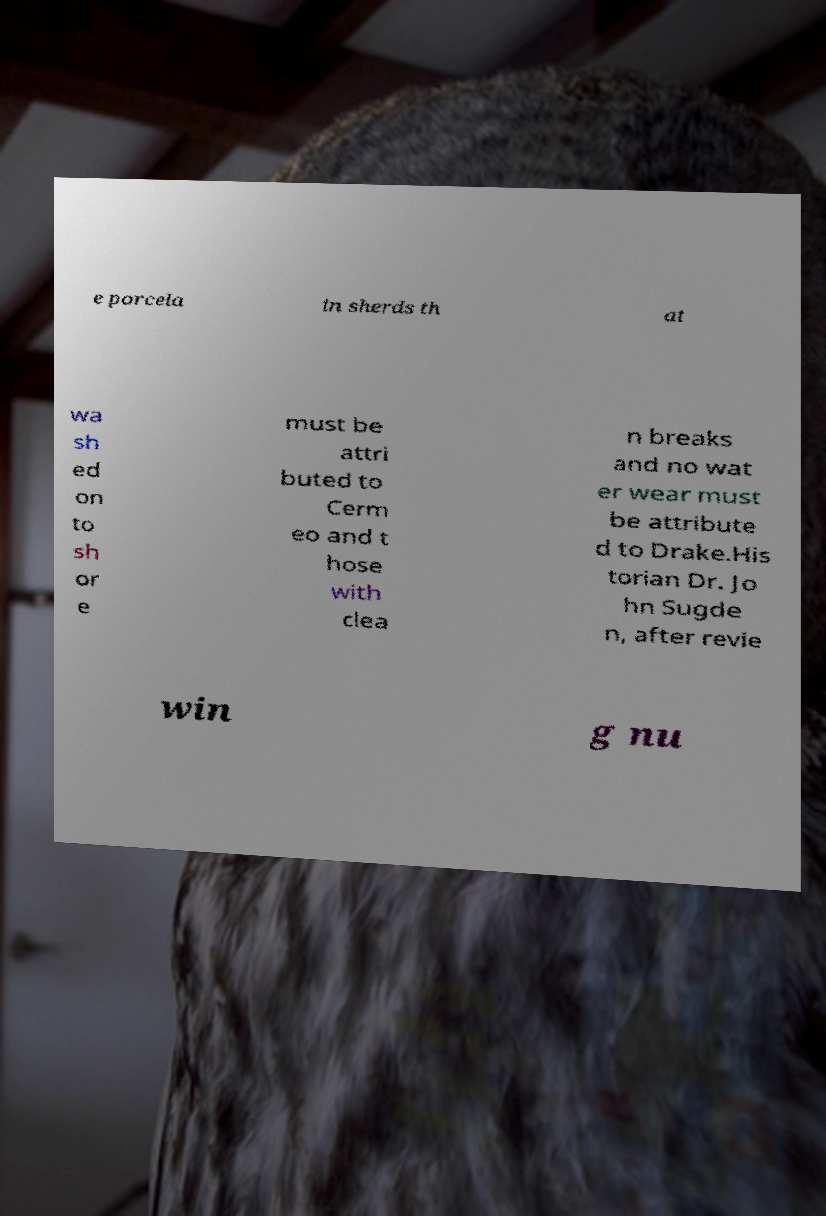Can you accurately transcribe the text from the provided image for me? e porcela in sherds th at wa sh ed on to sh or e must be attri buted to Cerm eo and t hose with clea n breaks and no wat er wear must be attribute d to Drake.His torian Dr. Jo hn Sugde n, after revie win g nu 